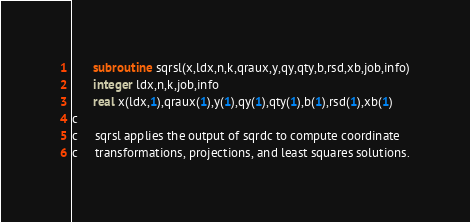<code> <loc_0><loc_0><loc_500><loc_500><_FORTRAN_>      subroutine sqrsl(x,ldx,n,k,qraux,y,qy,qty,b,rsd,xb,job,info)
      integer ldx,n,k,job,info
      real x(ldx,1),qraux(1),y(1),qy(1),qty(1),b(1),rsd(1),xb(1)
c
c     sqrsl applies the output of sqrdc to compute coordinate
c     transformations, projections, and least squares solutions.</code> 